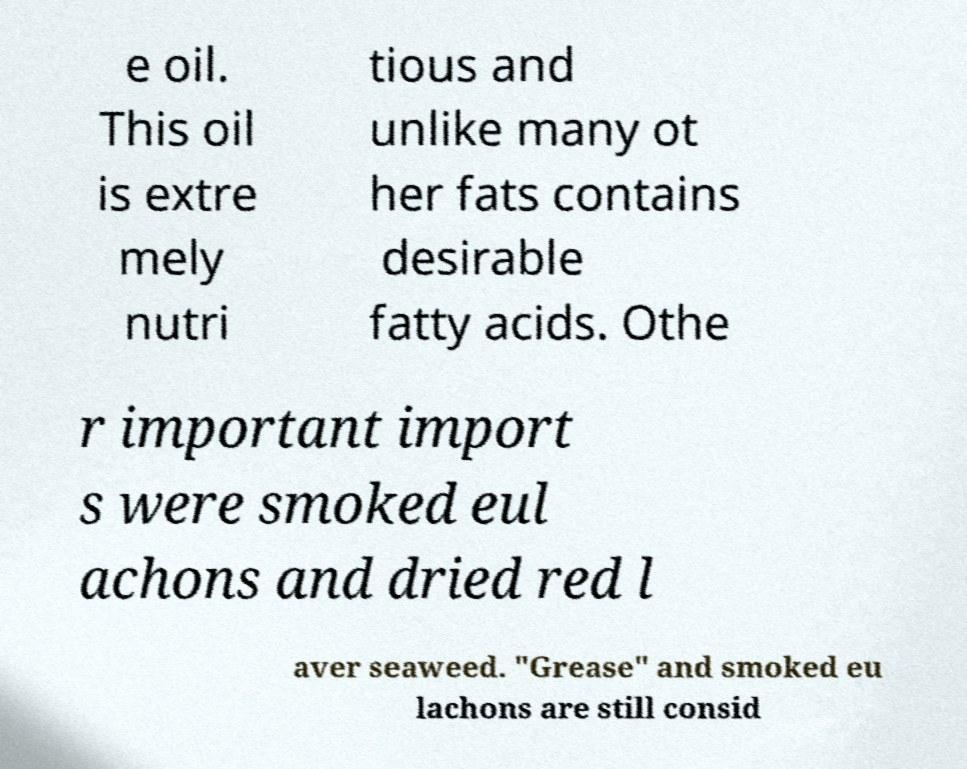I need the written content from this picture converted into text. Can you do that? e oil. This oil is extre mely nutri tious and unlike many ot her fats contains desirable fatty acids. Othe r important import s were smoked eul achons and dried red l aver seaweed. "Grease" and smoked eu lachons are still consid 